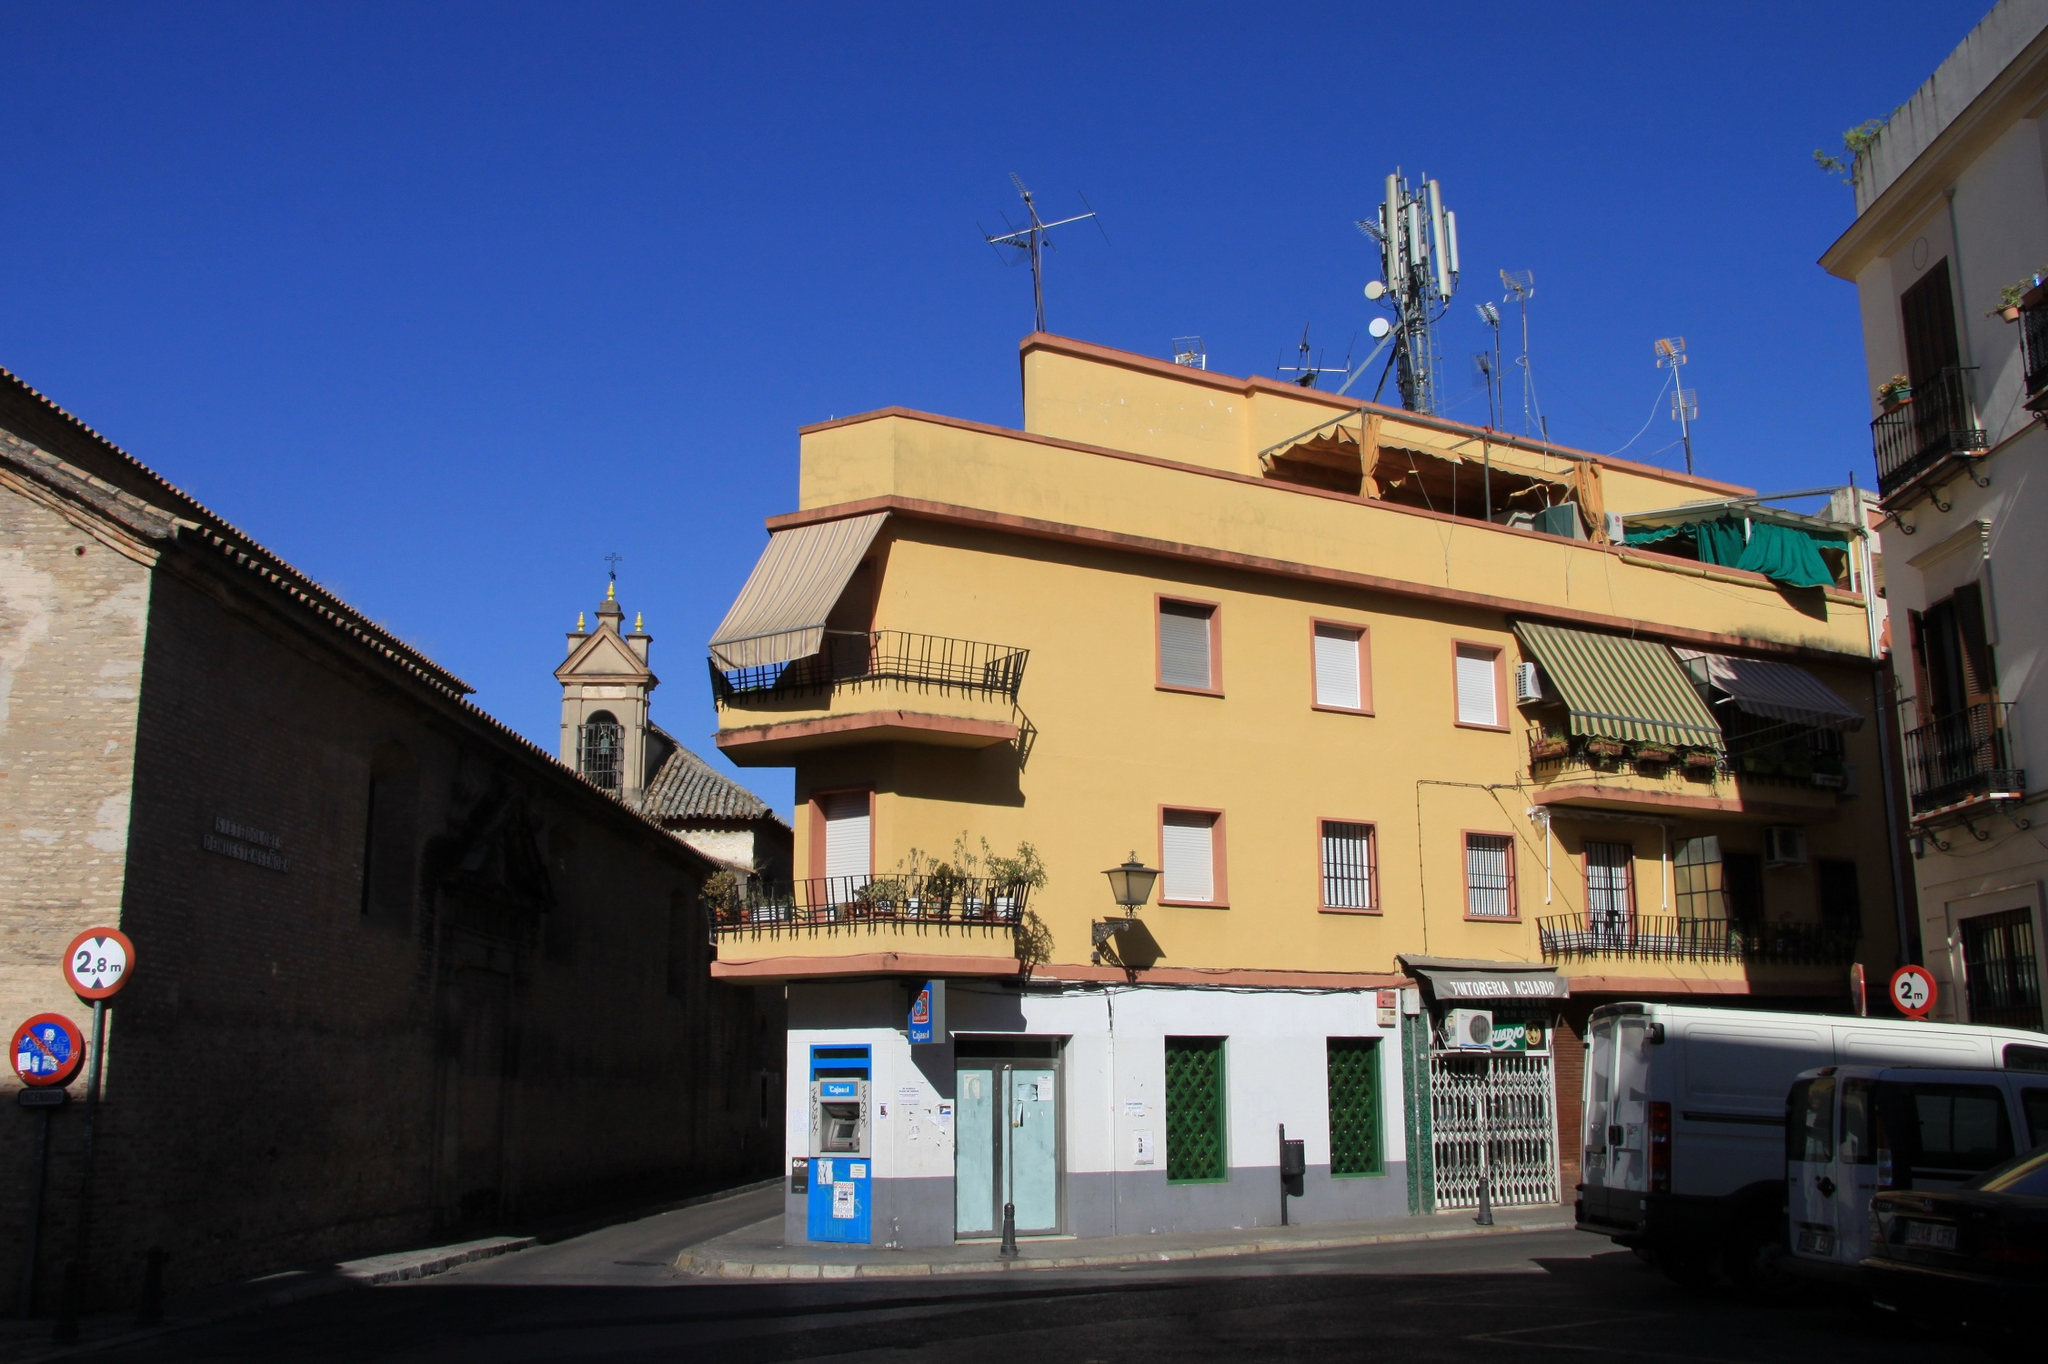Describe a long scenario involving a family moving into the yellow building. The Alvarez family, excited and hopeful, moves into the yellow building on a bright Saturday morning. The parents, Maria and Carlos, along with their two children, Lucia and Mateo, carefully navigate their way through the bustling street, their belongings carried up to their new apartment. As they step into their new home, they are welcomed by the gentle warmth of sunlight streaming through the windows. The apartment, with its high ceilings and spacious balconies, instantly feels like a cozy haven. Maria begins to unpack, setting up the kitchen and hanging family photos on the walls, while Carlos and the children explore the neighborhood. They visit the nearby park, meet their new neighbors, and even stop by the church to admire its historic architecture. By the evening, Lucia and Mateo have made friends with other children in the building, and the family gathers on the balcony for dinner. The view of the street below, with the lively activity and the calming beauty of the setting sun, assures them that this new chapter in the yellow building will be filled with happiness and cherished memories. As night falls, the city lights twinkle, and the gentle murmur of the street creates a soothing lullaby, welcoming the Alvarez family to their new home. 